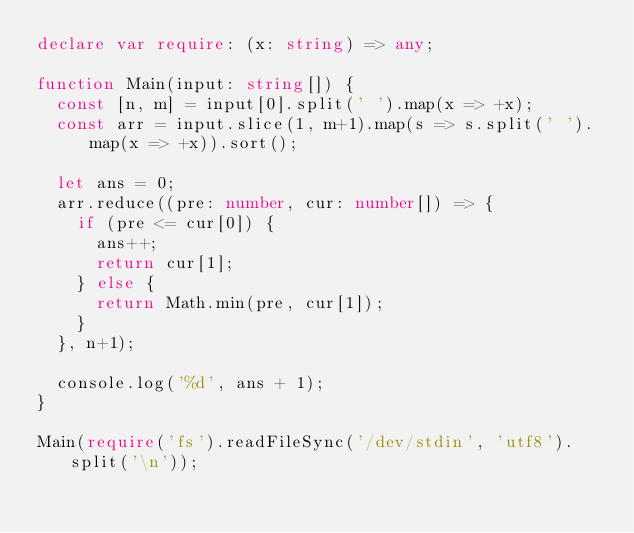<code> <loc_0><loc_0><loc_500><loc_500><_TypeScript_>declare var require: (x: string) => any;

function Main(input: string[]) {
  const [n, m] = input[0].split(' ').map(x => +x);
  const arr = input.slice(1, m+1).map(s => s.split(' ').map(x => +x)).sort();

  let ans = 0;
  arr.reduce((pre: number, cur: number[]) => {
    if (pre <= cur[0]) {
      ans++;
      return cur[1];
    } else {
      return Math.min(pre, cur[1]);
    }
  }, n+1);

  console.log('%d', ans + 1);
}

Main(require('fs').readFileSync('/dev/stdin', 'utf8').split('\n'));
</code> 